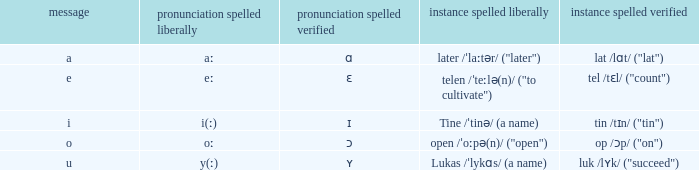If pronunciation spelled checked is "ʏ", what is the corresponding pronunciation spelled free? Y(ː). 